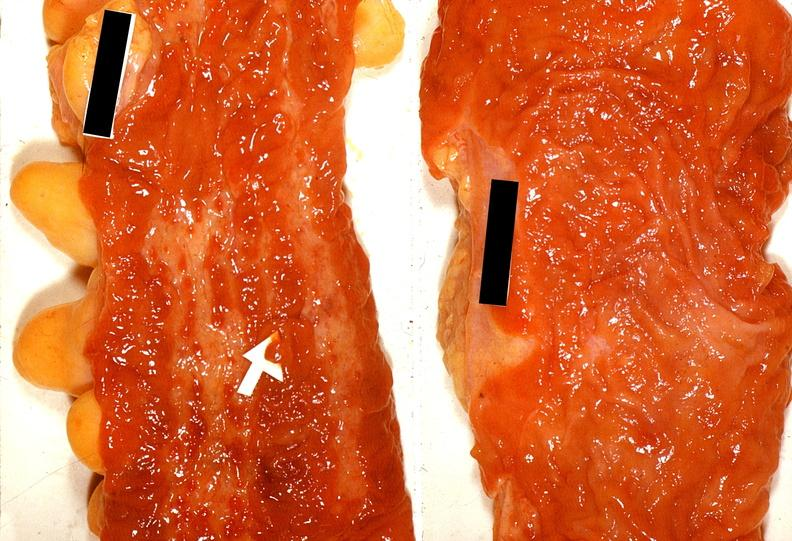does this image show colon, ulcerative colitis?
Answer the question using a single word or phrase. Yes 